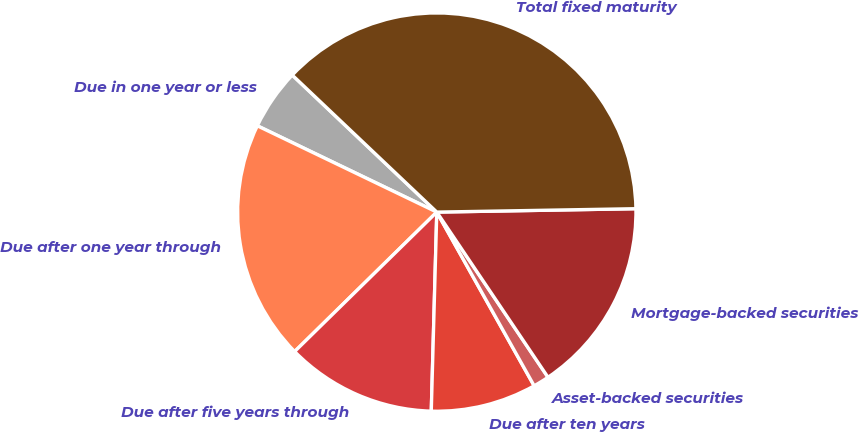<chart> <loc_0><loc_0><loc_500><loc_500><pie_chart><fcel>Due in one year or less<fcel>Due after one year through<fcel>Due after five years through<fcel>Due after ten years<fcel>Asset-backed securities<fcel>Mortgage-backed securities<fcel>Total fixed maturity<nl><fcel>4.94%<fcel>19.48%<fcel>12.21%<fcel>8.57%<fcel>1.3%<fcel>15.84%<fcel>37.65%<nl></chart> 